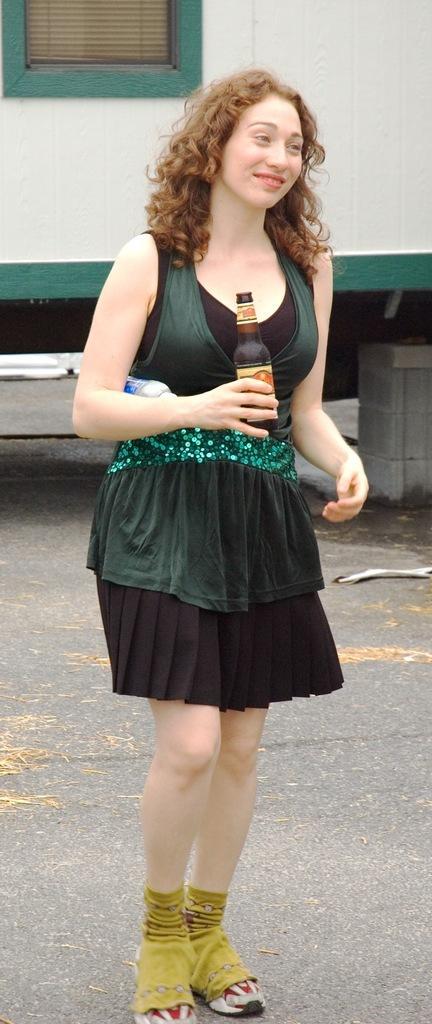In one or two sentences, can you explain what this image depicts? In the image we can see there is a woman who is standing and holding a wine bottle in her hand and she is wearing a green colour dress. 